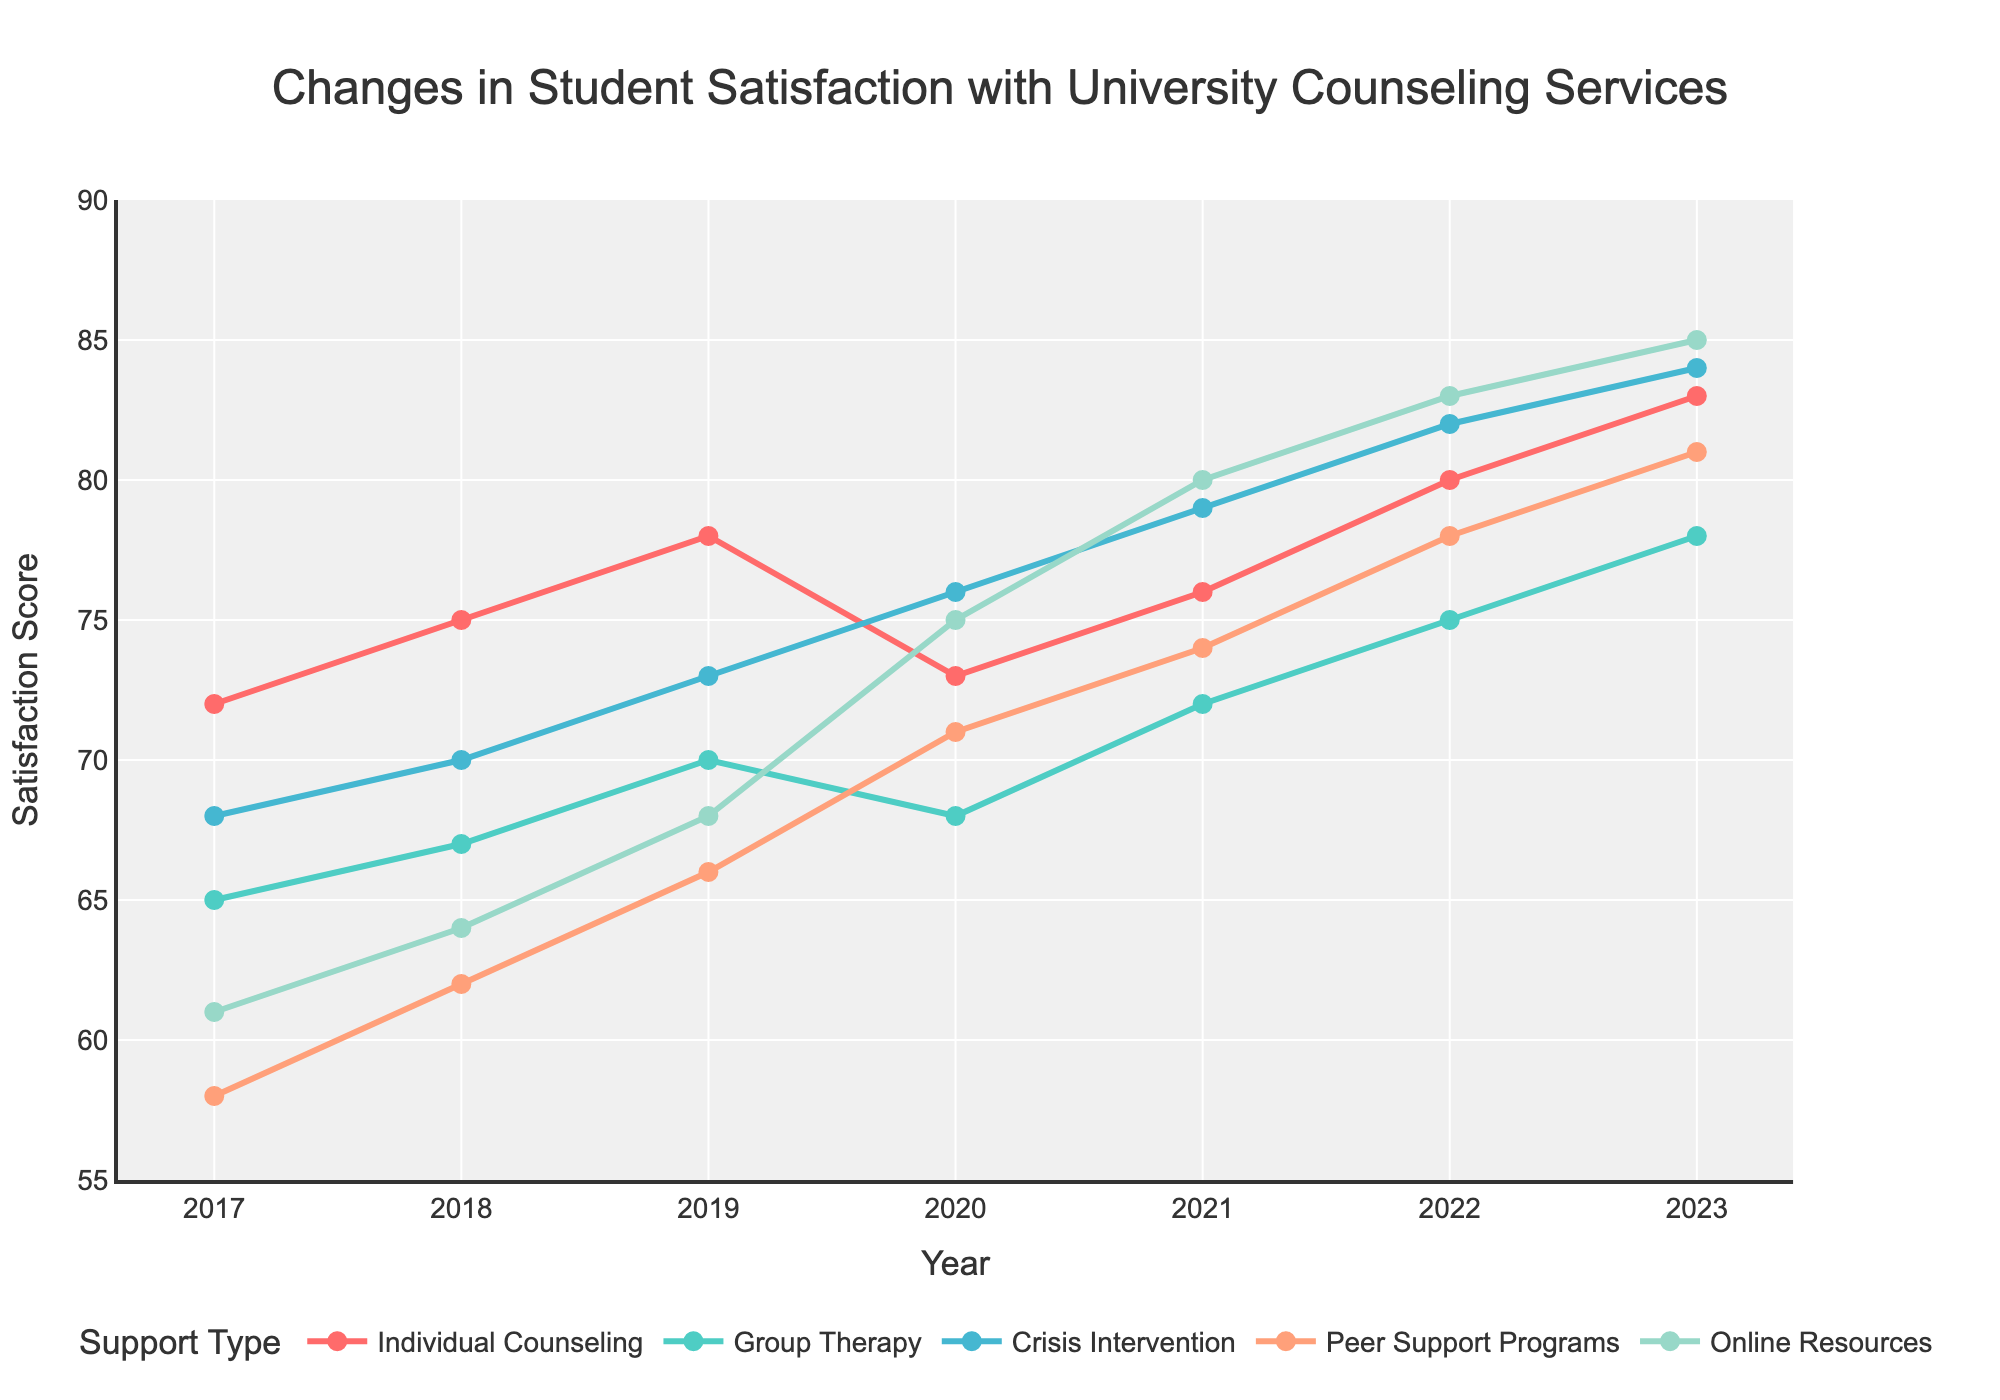Which support type had the highest student satisfaction score in 2023? To find the answer, look at the data points for 2023. The scores for the various supports are: Individual Counseling (83), Group Therapy (78), Crisis Intervention (84), Peer Support Programs (81), and Online Resources (85). The highest score among these is 85 for Online Resources.
Answer: Online Resources How did the satisfaction score for Individual Counseling change from 2017 to 2020? Compare the satisfaction scores for Individual Counseling in 2017 and 2020. The score in 2017 was 72, and in 2020 it was 73. The change is 73 - 72 = 1.
Answer: Increased by 1 Which year saw the biggest increase in satisfaction for Peer Support Programs? Evaluate the year-over-year changes for Peer Support Programs: 2017 to 2018 (62-58=4), 2018 to 2019 (66-62=4), 2019 to 2020 (71-66=5), 2020 to 2021 (74-71=3), 2021 to 2022 (78-74=4), and 2022 to 2023 (81-78=3). The largest increase is from 2019 to 2020 by 5 points.
Answer: 2019 to 2020 What was the average satisfaction score for Crisis Intervention over the seven years shown? Calculate the average by summing the scores for Crisis Intervention over each year and dividing by the number of years: (68 + 70 + 73 + 76 + 79 + 82 + 84) / 7 = 532 / 7 ≈ 76.
Answer: 76 